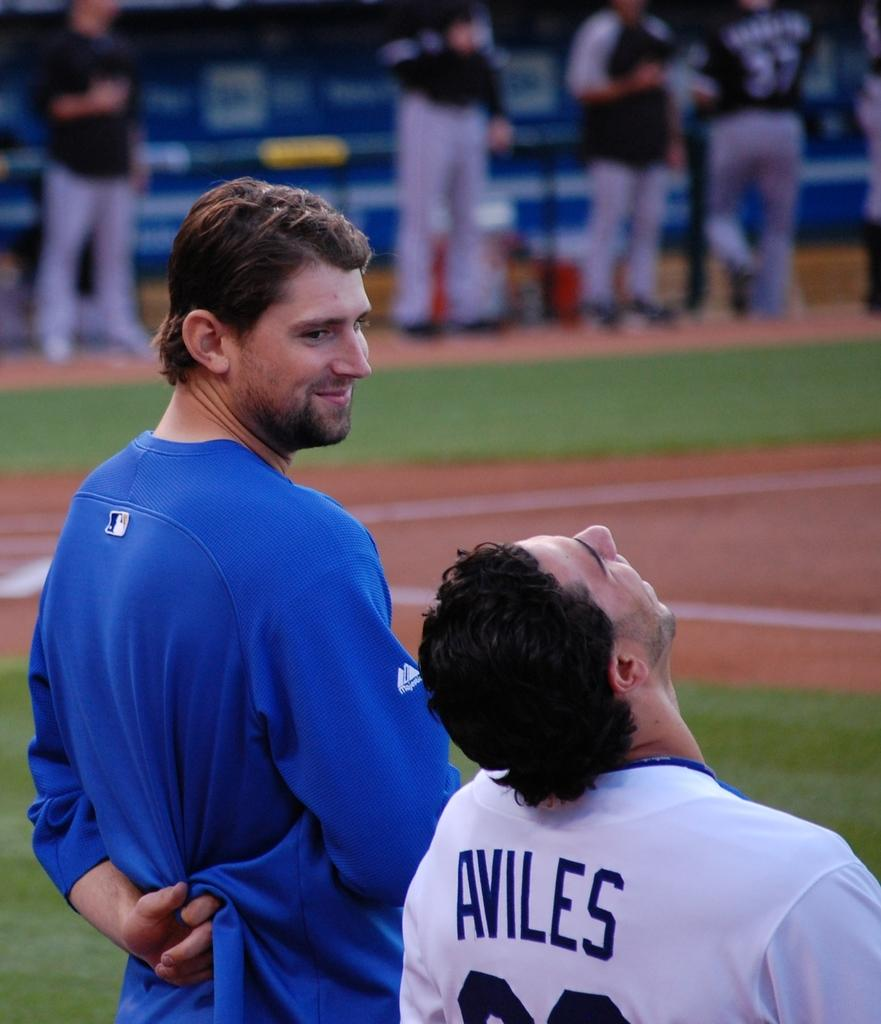<image>
Relay a brief, clear account of the picture shown. a player that has the word aviles on the back of their baseball jersey 